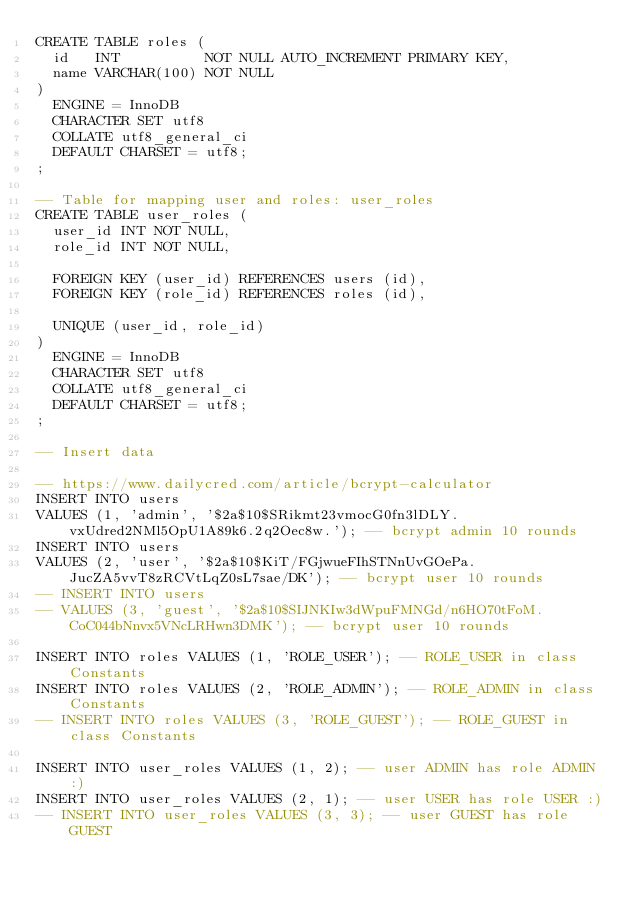Convert code to text. <code><loc_0><loc_0><loc_500><loc_500><_SQL_>CREATE TABLE roles (
  id   INT          NOT NULL AUTO_INCREMENT PRIMARY KEY,
  name VARCHAR(100) NOT NULL
)
  ENGINE = InnoDB
  CHARACTER SET utf8
  COLLATE utf8_general_ci
  DEFAULT CHARSET = utf8;
;

-- Table for mapping user and roles: user_roles
CREATE TABLE user_roles (
  user_id INT NOT NULL,
  role_id INT NOT NULL,

  FOREIGN KEY (user_id) REFERENCES users (id),
  FOREIGN KEY (role_id) REFERENCES roles (id),

  UNIQUE (user_id, role_id)
)
  ENGINE = InnoDB
  CHARACTER SET utf8
  COLLATE utf8_general_ci
  DEFAULT CHARSET = utf8;
;

-- Insert data

-- https://www.dailycred.com/article/bcrypt-calculator
INSERT INTO users
VALUES (1, 'admin', '$2a$10$SRikmt23vmocG0fn3lDLY.vxUdred2NMl5OpU1A89k6.2q2Oec8w.'); -- bcrypt admin 10 rounds
INSERT INTO users
VALUES (2, 'user', '$2a$10$KiT/FGjwueFIhSTNnUvGOePa.JucZA5vvT8zRCVtLqZ0sL7sae/DK'); -- bcrypt user 10 rounds
-- INSERT INTO users
-- VALUES (3, 'guest', '$2a$10$SIJNKIw3dWpuFMNGd/n6HO70tFoM.CoC044bNnvx5VNcLRHwn3DMK'); -- bcrypt user 10 rounds

INSERT INTO roles VALUES (1, 'ROLE_USER'); -- ROLE_USER in class Constants
INSERT INTO roles VALUES (2, 'ROLE_ADMIN'); -- ROLE_ADMIN in class Constants
-- INSERT INTO roles VALUES (3, 'ROLE_GUEST'); -- ROLE_GUEST in class Constants

INSERT INTO user_roles VALUES (1, 2); -- user ADMIN has role ADMIN :)
INSERT INTO user_roles VALUES (2, 1); -- user USER has role USER :)
-- INSERT INTO user_roles VALUES (3, 3); -- user GUEST has role GUEST
</code> 